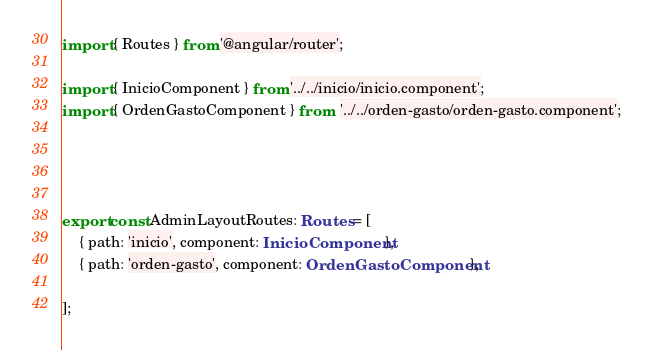<code> <loc_0><loc_0><loc_500><loc_500><_TypeScript_>import { Routes } from '@angular/router';

import { InicioComponent } from '../../inicio/inicio.component';
import { OrdenGastoComponent } from  '../../orden-gasto/orden-gasto.component';




export const AdminLayoutRoutes: Routes = [
    { path: 'inicio', component: InicioComponent },
    { path: 'orden-gasto', component: OrdenGastoComponent},

];
</code> 